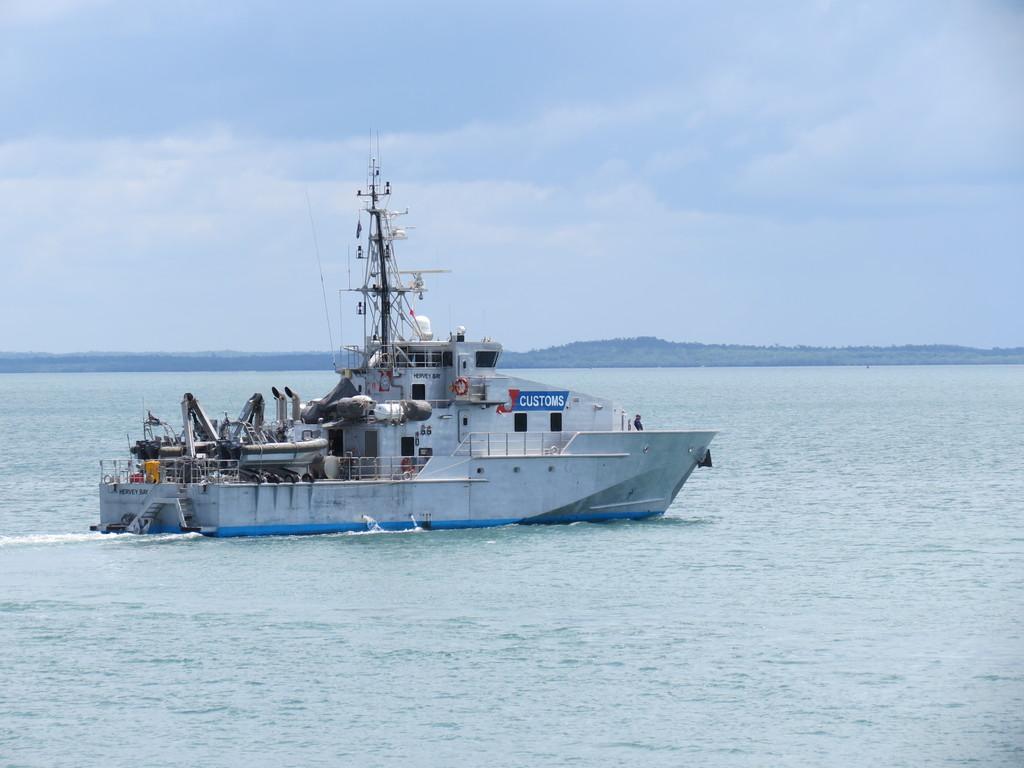What is the main setting of the image? There is an ocean in the image. What is moving on the ocean? There is a ship moving on the ocean. What is visible in the sky in the image? The sky is full of clouds. Can you see a zebra or a pan in the image? No, there is no zebra or pan present in the image. What type of cracker is floating on the ocean in the image? There is no cracker present in the image; it features an ocean with a ship moving on it and a cloudy sky. 